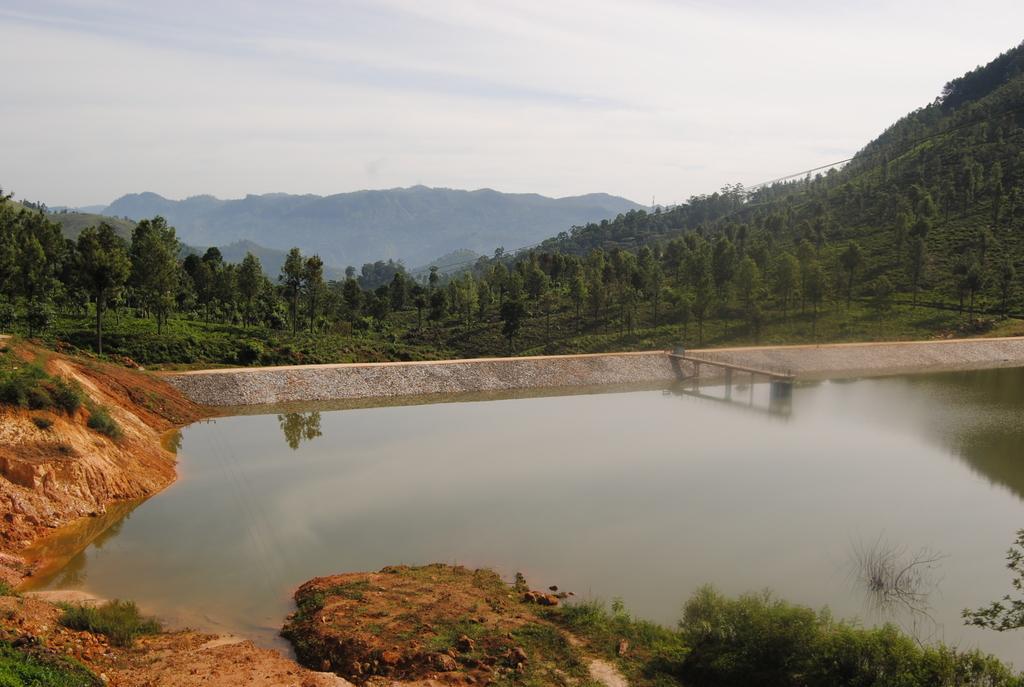Can you describe this image briefly? There is muddy texture and greenery at the bottom side, there is water and a dock in the center. There are trees, mountains and sky in the background area. 